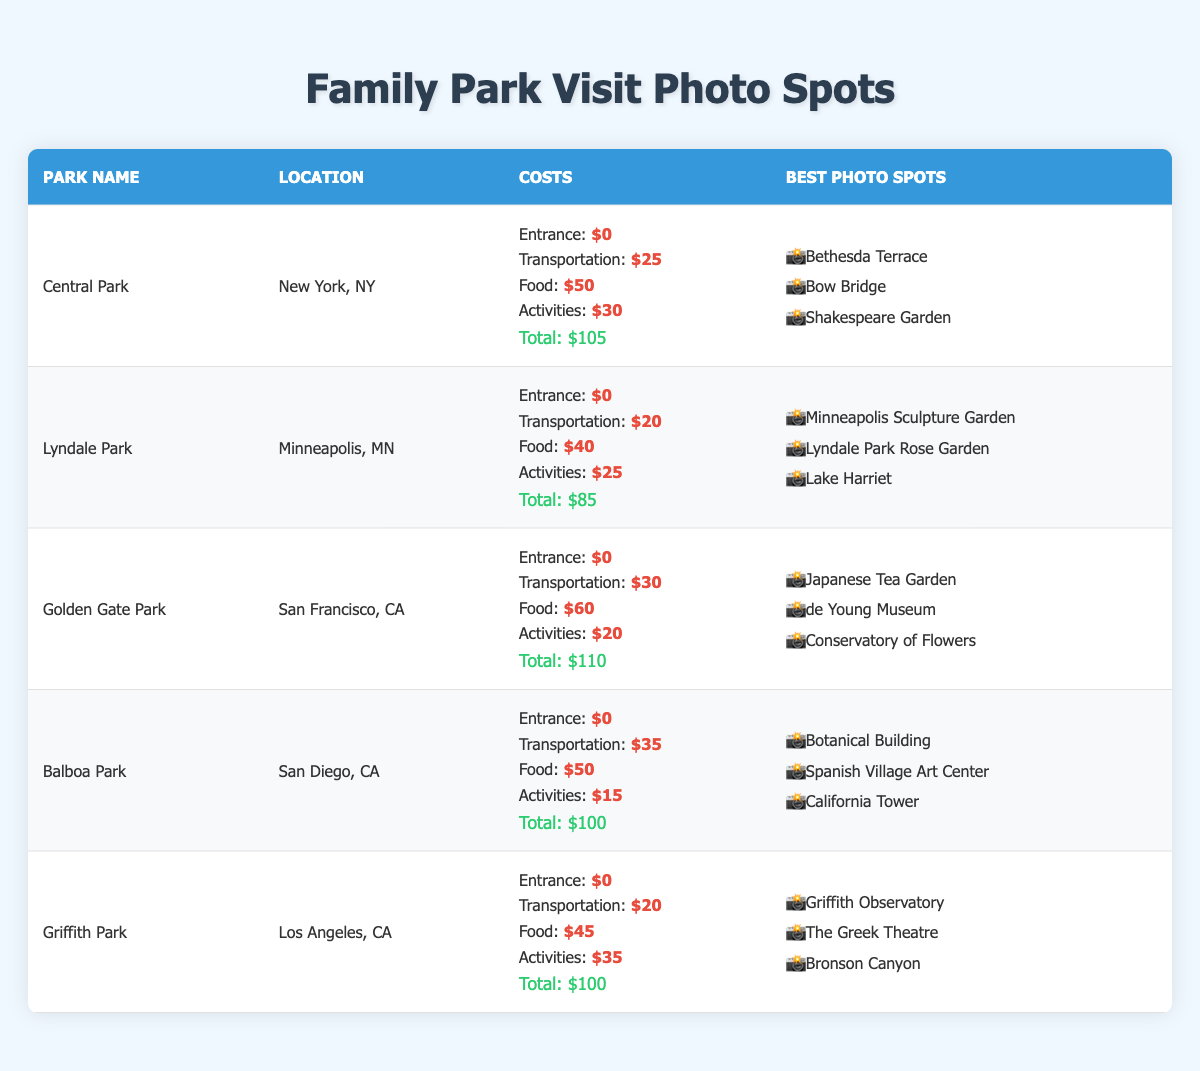What is the total cost of visiting Lyndale Park? The total cost for visiting Lyndale Park is listed in the table under the "Total Cost" section, which is $85.
Answer: 85 Which park has the highest total cost? By comparing the total costs of all parks listed, we see that Golden Gate Park has the highest total cost of $110.
Answer: Golden Gate Park Is there an entrance fee for Central Park? The table shows that the entrance fee for Central Park is $0, meaning there is no entrance fee.
Answer: No What is the average food cost of the parks listed? To calculate the average food cost, we sum up the food costs from each park: $50 + $40 + $60 + $50 + $45 = $245. We then divide by the number of parks (5). Therefore, the average food cost is $245 / 5 = $49.
Answer: 49 Which park has the least total cost and what is that cost? By examining the total costs of each park, we find that Lyndale Park has the least total cost of $85.
Answer: Lyndale Park, 85 Are there any parks where the total cost exceeds $100? By inspecting the total costs, we see that both Golden Gate Park ($110) and Central Park ($105) have costs that exceed $100.
Answer: Yes What is the transportation cost difference between Balboa Park and Griffith Park? The transportation cost for Balboa Park is $35 and for Griffith Park is $20. The difference is calculated as $35 - $20 = $15.
Answer: 15 How many total photo spots are available in Central Park and Balboa Park combined? Central Park has 3 photo spots and Balboa Park also has 3 photo spots, combining them totals to 3 + 3 = 6 photo spots.
Answer: 6 Which park has more photo spots, Golden Gate Park or Griffith Park? Golden Gate Park has 3 photo spots, while Griffith Park also has 3 photo spots. Since both have the same number of photo spots, neither park has more.
Answer: Neither 